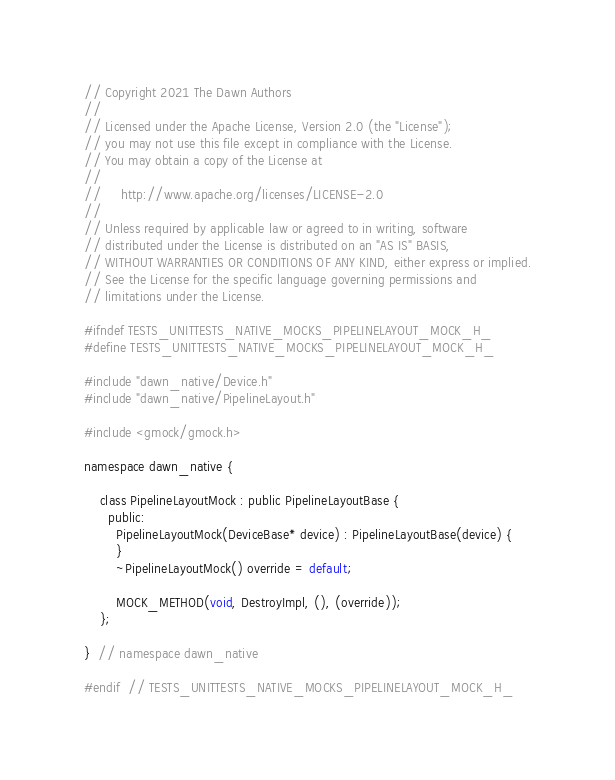<code> <loc_0><loc_0><loc_500><loc_500><_C_>// Copyright 2021 The Dawn Authors
//
// Licensed under the Apache License, Version 2.0 (the "License");
// you may not use this file except in compliance with the License.
// You may obtain a copy of the License at
//
//     http://www.apache.org/licenses/LICENSE-2.0
//
// Unless required by applicable law or agreed to in writing, software
// distributed under the License is distributed on an "AS IS" BASIS,
// WITHOUT WARRANTIES OR CONDITIONS OF ANY KIND, either express or implied.
// See the License for the specific language governing permissions and
// limitations under the License.

#ifndef TESTS_UNITTESTS_NATIVE_MOCKS_PIPELINELAYOUT_MOCK_H_
#define TESTS_UNITTESTS_NATIVE_MOCKS_PIPELINELAYOUT_MOCK_H_

#include "dawn_native/Device.h"
#include "dawn_native/PipelineLayout.h"

#include <gmock/gmock.h>

namespace dawn_native {

    class PipelineLayoutMock : public PipelineLayoutBase {
      public:
        PipelineLayoutMock(DeviceBase* device) : PipelineLayoutBase(device) {
        }
        ~PipelineLayoutMock() override = default;

        MOCK_METHOD(void, DestroyImpl, (), (override));
    };

}  // namespace dawn_native

#endif  // TESTS_UNITTESTS_NATIVE_MOCKS_PIPELINELAYOUT_MOCK_H_
</code> 